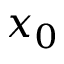<formula> <loc_0><loc_0><loc_500><loc_500>x _ { 0 }</formula> 